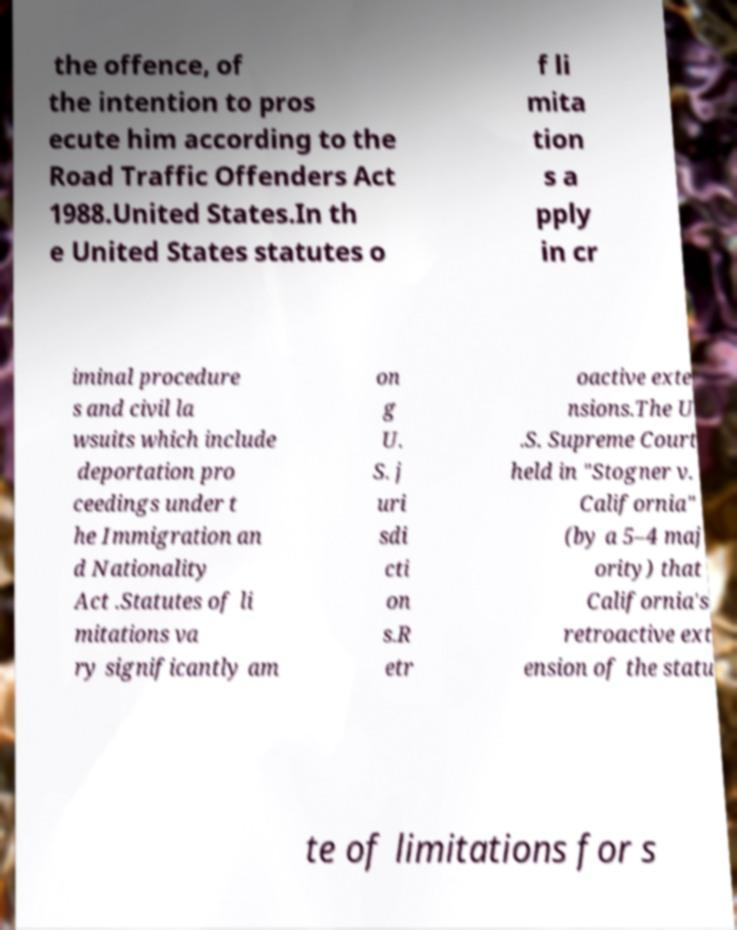There's text embedded in this image that I need extracted. Can you transcribe it verbatim? the offence, of the intention to pros ecute him according to the Road Traffic Offenders Act 1988.United States.In th e United States statutes o f li mita tion s a pply in cr iminal procedure s and civil la wsuits which include deportation pro ceedings under t he Immigration an d Nationality Act .Statutes of li mitations va ry significantly am on g U. S. j uri sdi cti on s.R etr oactive exte nsions.The U .S. Supreme Court held in "Stogner v. California" (by a 5–4 maj ority) that California's retroactive ext ension of the statu te of limitations for s 